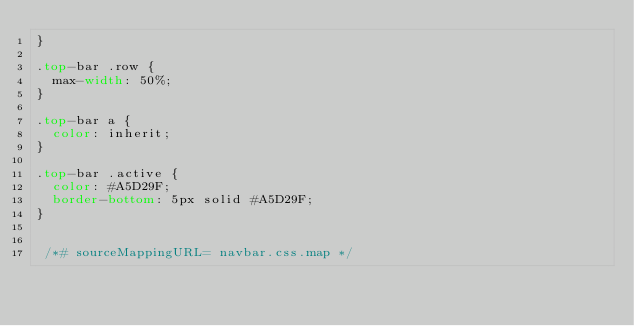Convert code to text. <code><loc_0><loc_0><loc_500><loc_500><_CSS_>}

.top-bar .row {
  max-width: 50%;
}

.top-bar a {
  color: inherit;
}

.top-bar .active {
  color: #A5D29F;
  border-bottom: 5px solid #A5D29F;
}
 

 /*# sourceMappingURL= navbar.css.map */</code> 